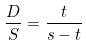Convert formula to latex. <formula><loc_0><loc_0><loc_500><loc_500>\frac { D } { S } = \frac { t } { s - t }</formula> 